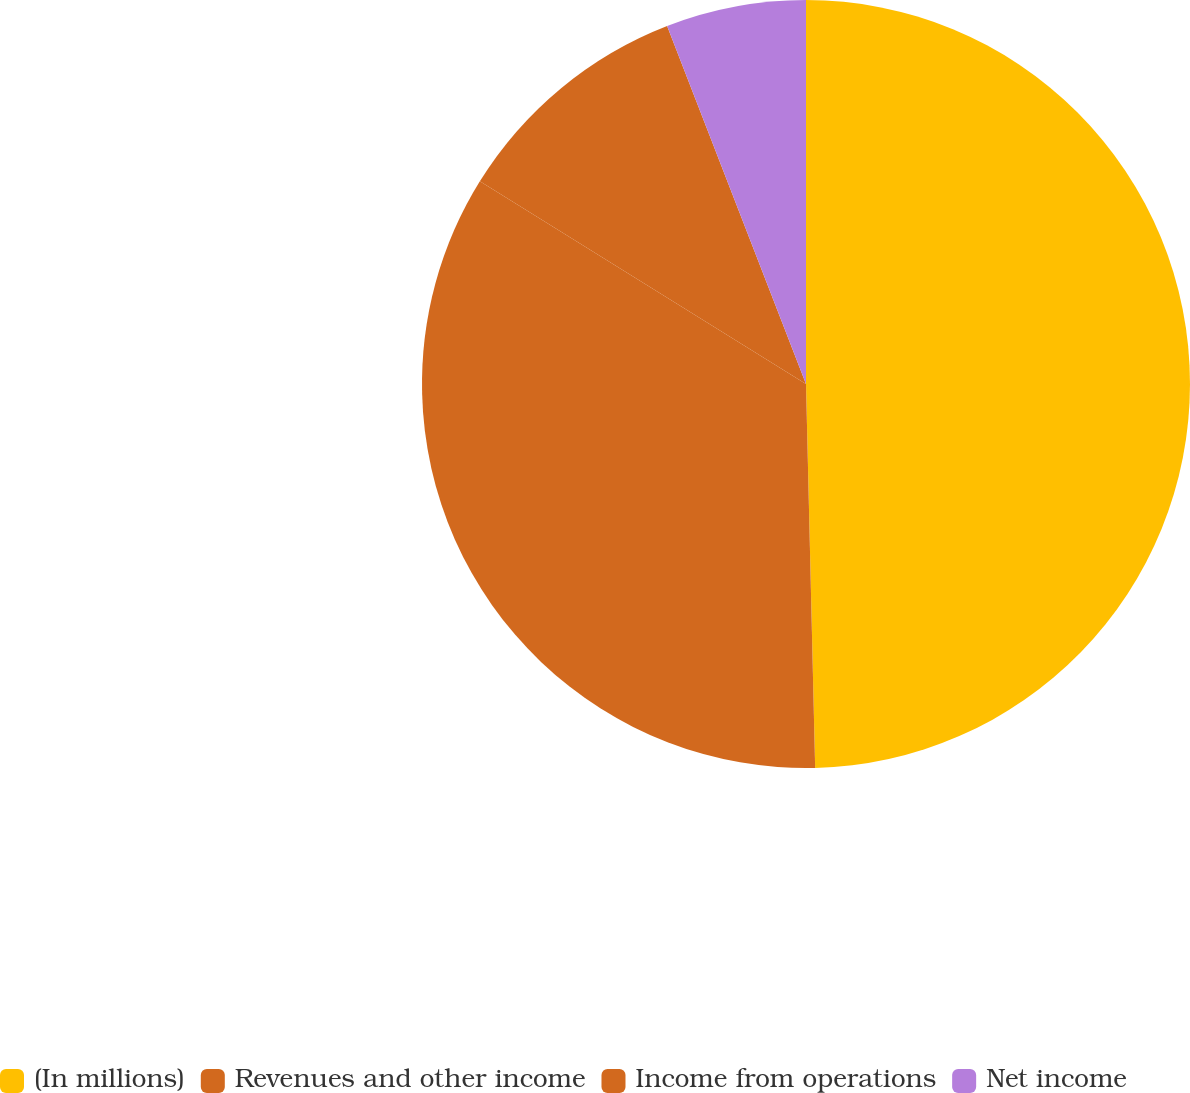Convert chart to OTSL. <chart><loc_0><loc_0><loc_500><loc_500><pie_chart><fcel>(In millions)<fcel>Revenues and other income<fcel>Income from operations<fcel>Net income<nl><fcel>49.62%<fcel>34.23%<fcel>10.26%<fcel>5.89%<nl></chart> 